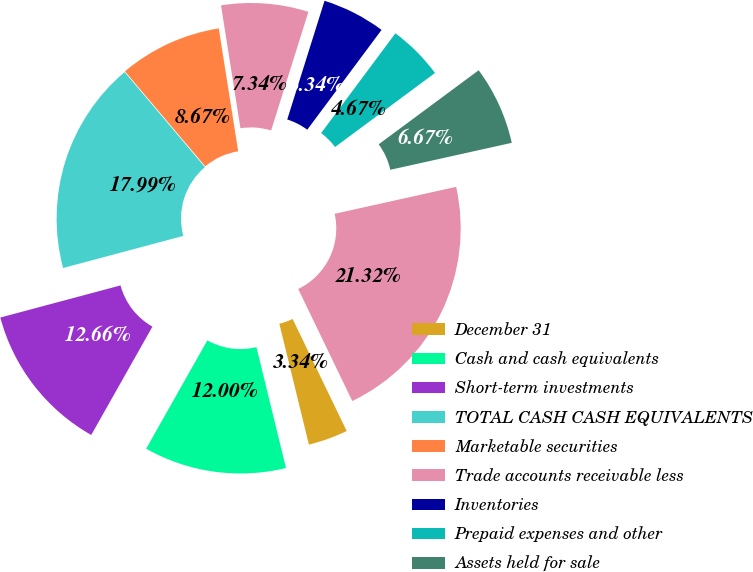Convert chart to OTSL. <chart><loc_0><loc_0><loc_500><loc_500><pie_chart><fcel>December 31<fcel>Cash and cash equivalents<fcel>Short-term investments<fcel>TOTAL CASH CASH EQUIVALENTS<fcel>Marketable securities<fcel>Trade accounts receivable less<fcel>Inventories<fcel>Prepaid expenses and other<fcel>Assets held for sale<fcel>TOTAL CURRENT ASSETS<nl><fcel>3.34%<fcel>12.0%<fcel>12.66%<fcel>17.99%<fcel>8.67%<fcel>7.34%<fcel>5.34%<fcel>4.67%<fcel>6.67%<fcel>21.32%<nl></chart> 